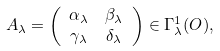<formula> <loc_0><loc_0><loc_500><loc_500>A _ { \lambda } & = \left ( \begin{array} { c c } \alpha _ { \lambda } & \beta _ { \lambda } \\ \gamma _ { \lambda } & \delta _ { \lambda } \end{array} \right ) \in \Gamma _ { \lambda } ^ { 1 } ( O ) ,</formula> 